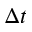<formula> <loc_0><loc_0><loc_500><loc_500>\Delta t</formula> 